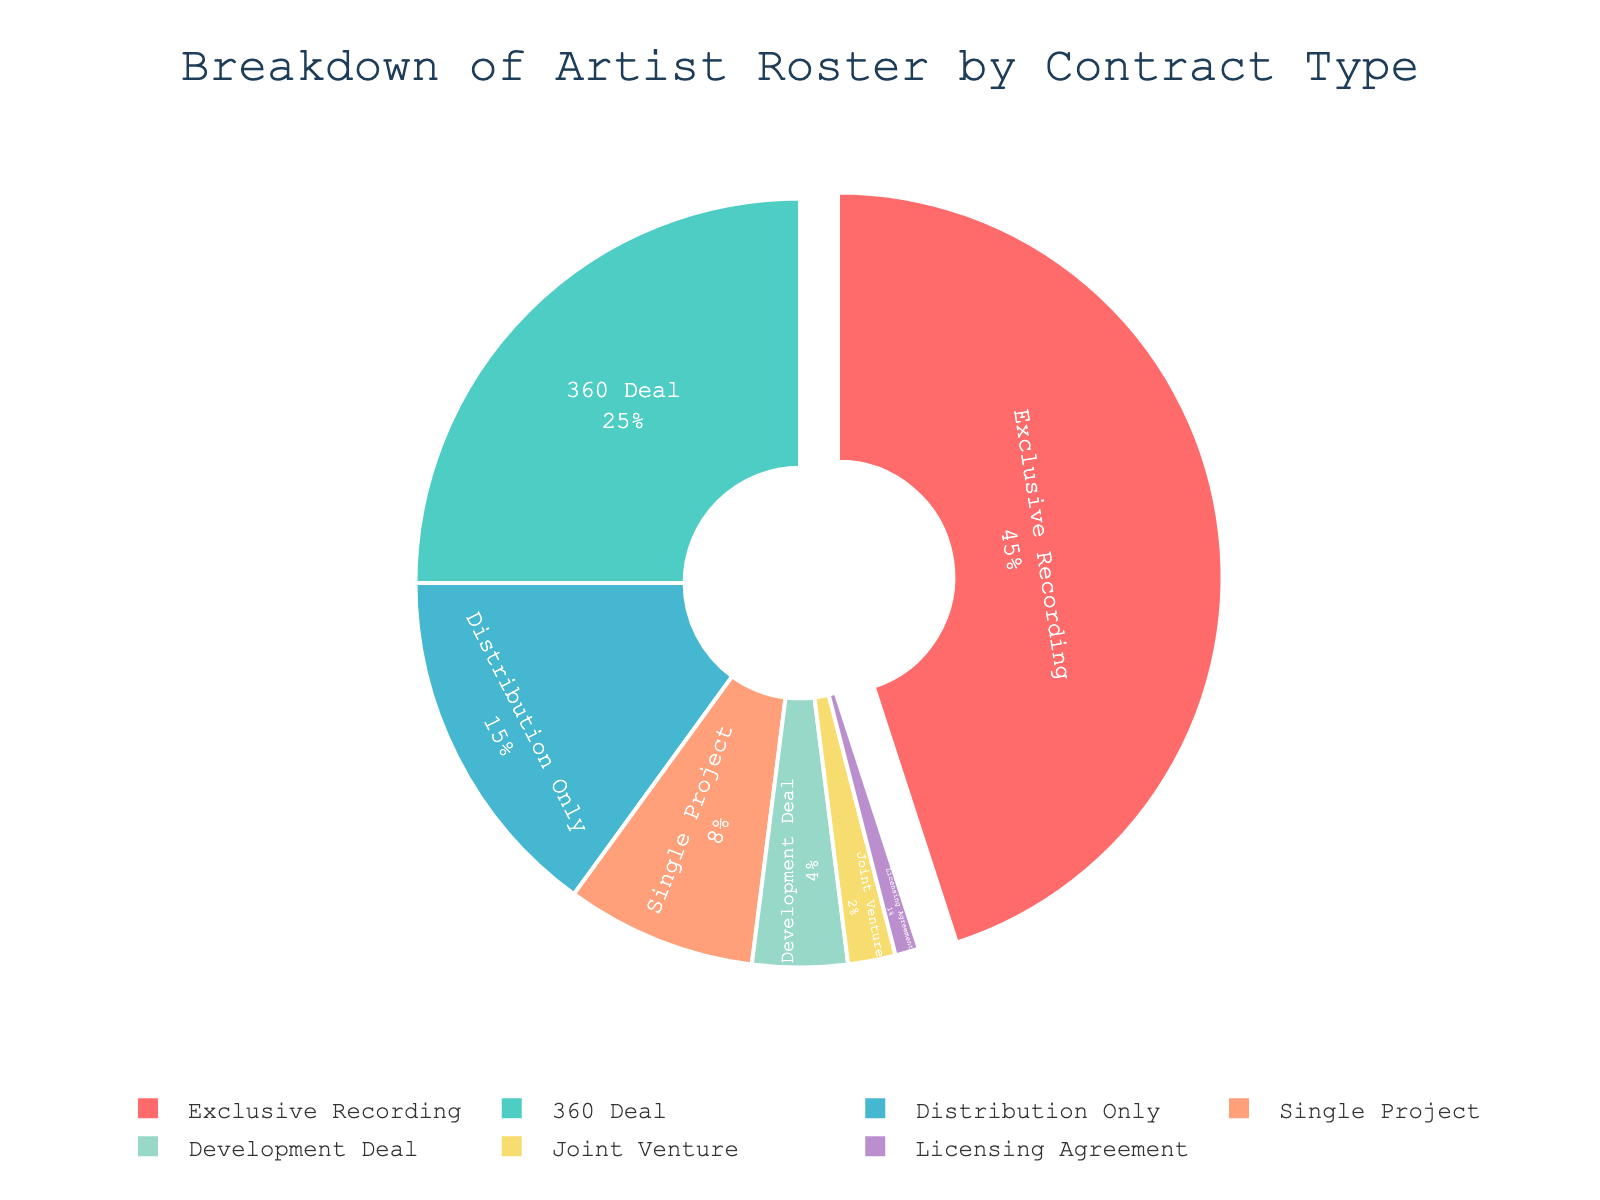What's the most common contract type on the artist roster? The "Exclusive Recording" section occupies the largest portion of the pie chart at 45%, making it the most common contract type.
Answer: Exclusive Recording What's the percentage of artists under "Single Project" and "Development Deal" contracts combined? Adding the percentages of "Single Project" (8%) and "Development Deal" (4%) gives a combined total percentage of 12%.
Answer: 12% Which contract type has the smallest percentage? The "Licensing Agreement" section is the smallest on the pie chart, representing 1% of the total.
Answer: Licensing Agreement How does the percentage of artists under "760 Deal" compare to those under "Distribution Only"? The "360 Deal" (25%) has a higher percentage of artists compared to "Distribution Only" (15%).
Answer: 360 Deal has a higher percentage What's the difference in percentage between "Exclusive Recording" and "360 Deal"? Subtracting the percentage of "360 Deal" (25%) from "Exclusive Recording" (45%) gives a difference of 20%.
Answer: 20% What is the combined percentage of the three least common contract types? Adding the percentages of "Development Deal" (4%), "Joint Venture" (2%), and "Licensing Agreement" (1%) gives a combined total of 7%.
Answer: 7% Which color represents the "360 Deal" segment on the pie chart? The "360 Deal" segment is colored in green, as indicated by the second position in the color sequence ('#4ECDC4').
Answer: Green Is the percentage of "Distribution Only" contracts greater than, less than, or equal to that of "Single Project"? The "Distribution Only" percentage (15%) is greater than that of "Single Project" (8%).
Answer: Greater than What is the relationship between the percentages of "Development Deal" and "Joint Venture" contracts? The percentage for "Development Deal" (4%) is greater than that for "Joint Venture" (2%).
Answer: Development Deal is greater How much larger is the "Exclusive Recording" contract percentage compared to the aggregate of "Single Project" and "Development Deal"? The "Exclusive Recording" percentage (45%) minus the combined total for "Single Project" (8%) and "Development Deal" (4%) is 33%.
Answer: 33% 